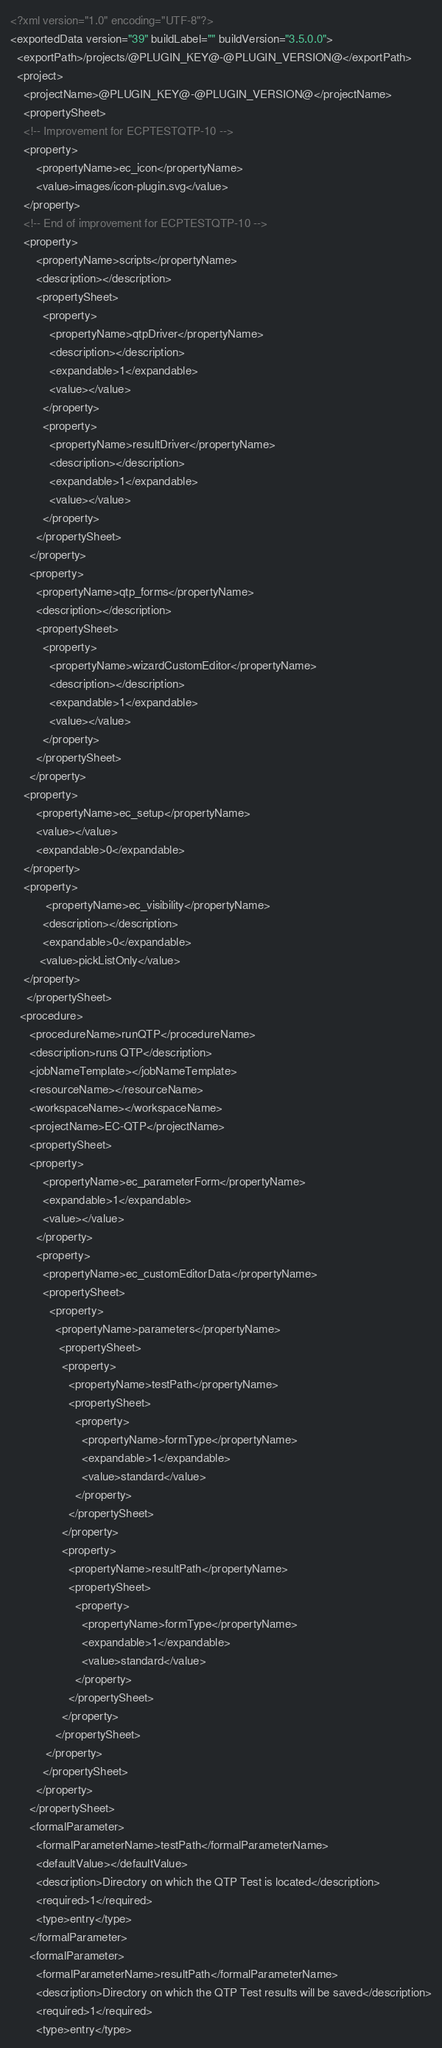<code> <loc_0><loc_0><loc_500><loc_500><_XML_><?xml version="1.0" encoding="UTF-8"?>
<exportedData version="39" buildLabel="" buildVersion="3.5.0.0">
  <exportPath>/projects/@PLUGIN_KEY@-@PLUGIN_VERSION@</exportPath>
  <project>
    <projectName>@PLUGIN_KEY@-@PLUGIN_VERSION@</projectName>
    <propertySheet>
    <!-- Improvement for ECPTESTQTP-10 -->
    <property>
        <propertyName>ec_icon</propertyName>
        <value>images/icon-plugin.svg</value>
    </property>
    <!-- End of improvement for ECPTESTQTP-10 -->
    <property>
        <propertyName>scripts</propertyName>
        <description></description>
        <propertySheet>
          <property>
            <propertyName>qtpDriver</propertyName>
            <description></description>
            <expandable>1</expandable>
            <value></value>
          </property>
		  <property>
            <propertyName>resultDriver</propertyName>
            <description></description>
            <expandable>1</expandable>
            <value></value>
          </property>
        </propertySheet>
      </property>
      <property>
        <propertyName>qtp_forms</propertyName>
        <description></description>
        <propertySheet>
          <property>
            <propertyName>wizardCustomEditor</propertyName>
            <description></description>
            <expandable>1</expandable>
            <value></value>
          </property>
        </propertySheet>
      </property>
    <property>
        <propertyName>ec_setup</propertyName>
        <value></value>
        <expandable>0</expandable>
    </property>
    <property>
           <propertyName>ec_visibility</propertyName>
          <description></description>
          <expandable>0</expandable>
         <value>pickListOnly</value>
    </property>
     </propertySheet>
   <procedure>
      <procedureName>runQTP</procedureName>
      <description>runs QTP</description>
      <jobNameTemplate></jobNameTemplate>
      <resourceName></resourceName>
      <workspaceName></workspaceName>
      <projectName>EC-QTP</projectName>
      <propertySheet>
	  <property>
		  <propertyName>ec_parameterForm</propertyName>
		  <expandable>1</expandable>
		  <value></value>
		</property>
        <property>
          <propertyName>ec_customEditorData</propertyName>
          <propertySheet>
            <property>
              <propertyName>parameters</propertyName>
               <propertySheet>
                <property>
                  <propertyName>testPath</propertyName>
                  <propertySheet>
                    <property>
                      <propertyName>formType</propertyName>
                      <expandable>1</expandable>
                      <value>standard</value>
                    </property>
                  </propertySheet>
                </property>
                <property>
                  <propertyName>resultPath</propertyName>
                  <propertySheet>
                    <property>
                      <propertyName>formType</propertyName>
                      <expandable>1</expandable>
                      <value>standard</value>
                    </property>
                  </propertySheet>
                </property>
              </propertySheet>
           </property>
          </propertySheet>
        </property>
      </propertySheet>
      <formalParameter>
        <formalParameterName>testPath</formalParameterName>
        <defaultValue></defaultValue>
        <description>Directory on which the QTP Test is located</description>
        <required>1</required>
        <type>entry</type>
      </formalParameter>
      <formalParameter>
        <formalParameterName>resultPath</formalParameterName>
        <description>Directory on which the QTP Test results will be saved</description>
        <required>1</required>
        <type>entry</type></code> 